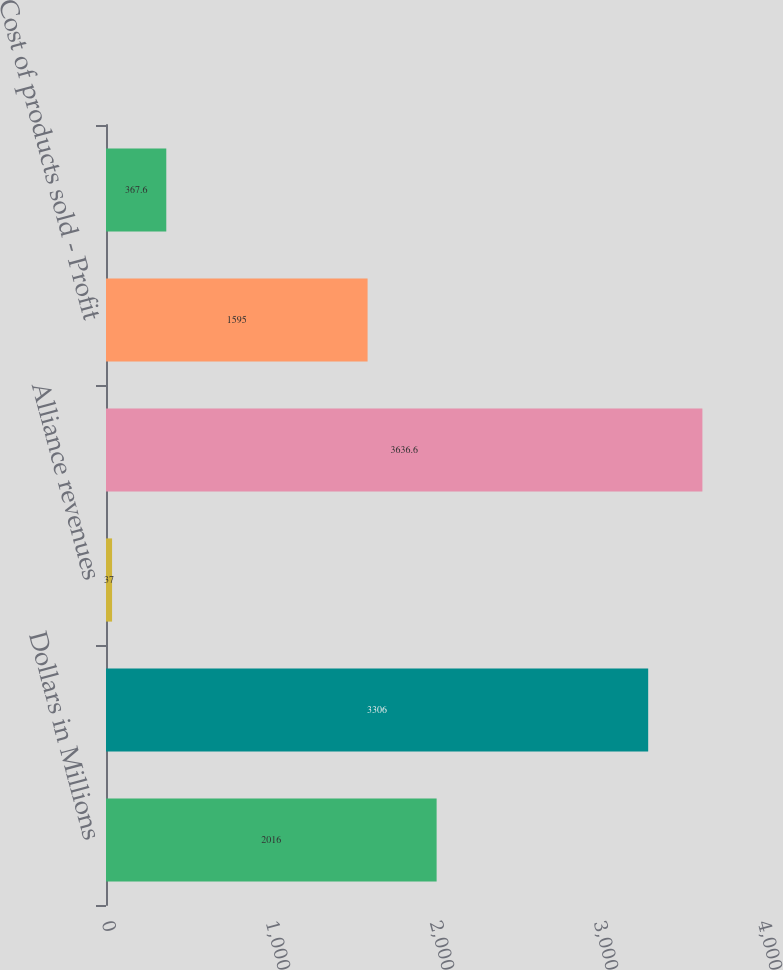Convert chart to OTSL. <chart><loc_0><loc_0><loc_500><loc_500><bar_chart><fcel>Dollars in Millions<fcel>Net product sales<fcel>Alliance revenues<fcel>Total Revenues<fcel>Cost of products sold - Profit<fcel>Other income (net) -<nl><fcel>2016<fcel>3306<fcel>37<fcel>3636.6<fcel>1595<fcel>367.6<nl></chart> 